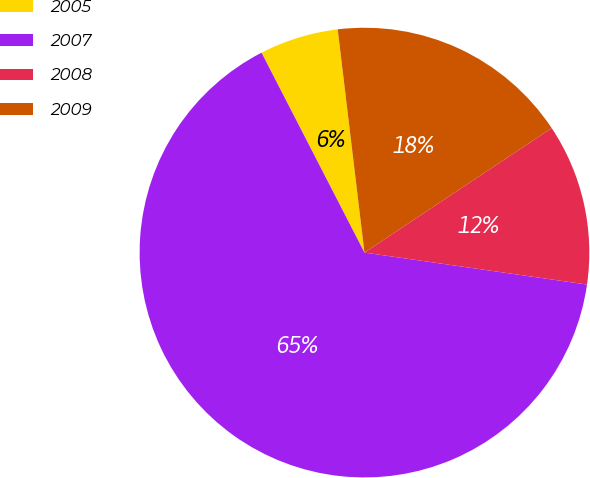<chart> <loc_0><loc_0><loc_500><loc_500><pie_chart><fcel>2005<fcel>2007<fcel>2008<fcel>2009<nl><fcel>5.67%<fcel>65.16%<fcel>11.61%<fcel>17.56%<nl></chart> 